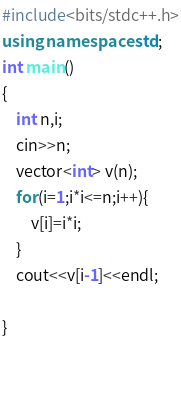Convert code to text. <code><loc_0><loc_0><loc_500><loc_500><_C++_>#include<bits/stdc++.h>
using namespace std;
int main()
{
    int n,i;
    cin>>n;
    vector<int> v(n);
    for(i=1;i*i<=n;i++){
        v[i]=i*i;
    }
    cout<<v[i-1]<<endl;
    
}

    
</code> 